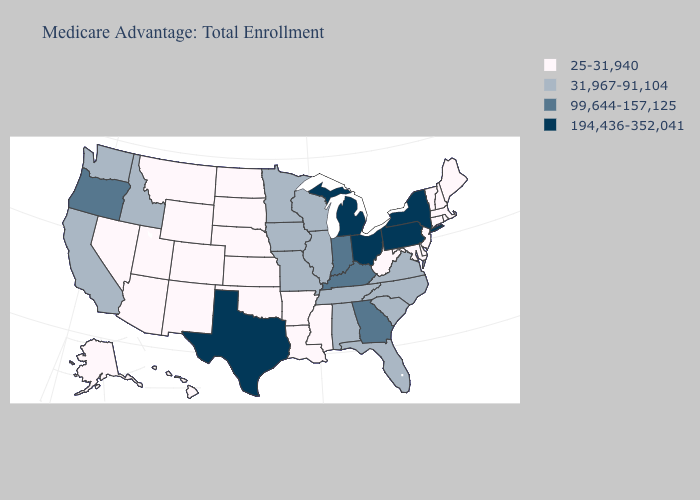Name the states that have a value in the range 31,967-91,104?
Concise answer only. Alabama, California, Florida, Iowa, Idaho, Illinois, Minnesota, Missouri, North Carolina, South Carolina, Tennessee, Virginia, Washington, Wisconsin. Name the states that have a value in the range 31,967-91,104?
Concise answer only. Alabama, California, Florida, Iowa, Idaho, Illinois, Minnesota, Missouri, North Carolina, South Carolina, Tennessee, Virginia, Washington, Wisconsin. What is the value of Minnesota?
Short answer required. 31,967-91,104. Among the states that border Massachusetts , which have the highest value?
Concise answer only. New York. Does Massachusetts have the same value as Idaho?
Be succinct. No. Among the states that border Virginia , which have the highest value?
Keep it brief. Kentucky. Which states have the lowest value in the USA?
Be succinct. Alaska, Arkansas, Arizona, Colorado, Connecticut, Delaware, Hawaii, Kansas, Louisiana, Massachusetts, Maryland, Maine, Mississippi, Montana, North Dakota, Nebraska, New Hampshire, New Jersey, New Mexico, Nevada, Oklahoma, Rhode Island, South Dakota, Utah, Vermont, West Virginia, Wyoming. Name the states that have a value in the range 194,436-352,041?
Answer briefly. Michigan, New York, Ohio, Pennsylvania, Texas. Is the legend a continuous bar?
Concise answer only. No. Does Pennsylvania have the lowest value in the Northeast?
Short answer required. No. What is the lowest value in the USA?
Give a very brief answer. 25-31,940. What is the highest value in the USA?
Be succinct. 194,436-352,041. What is the value of New York?
Give a very brief answer. 194,436-352,041. Is the legend a continuous bar?
Quick response, please. No. 